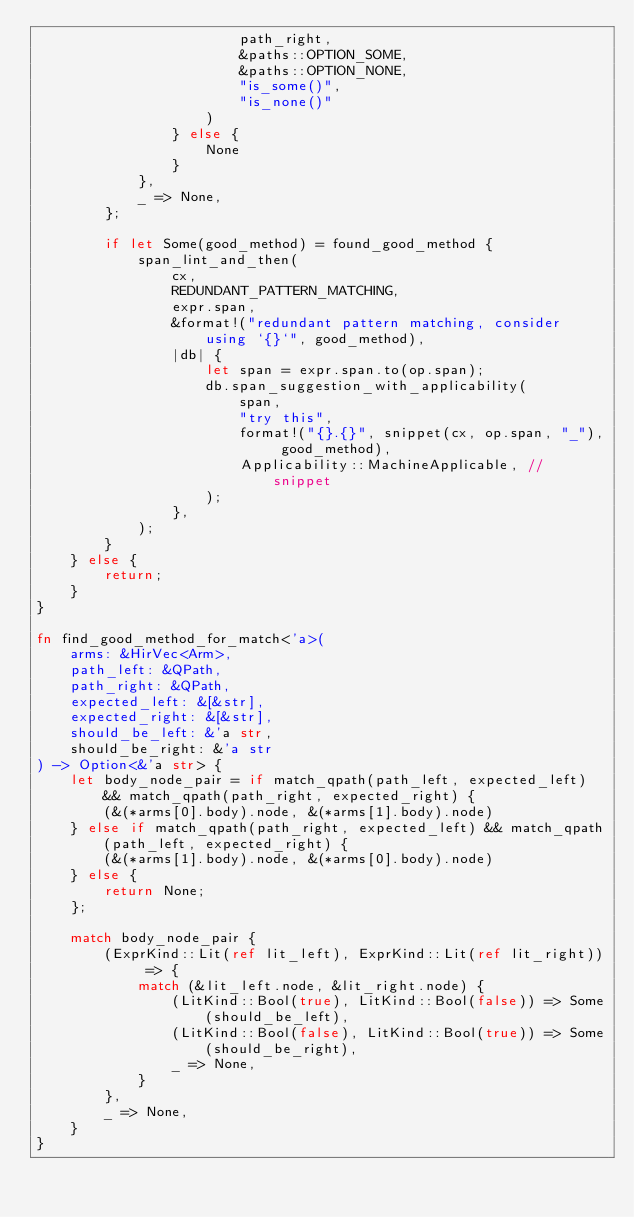<code> <loc_0><loc_0><loc_500><loc_500><_Rust_>                        path_right,
                        &paths::OPTION_SOME,
                        &paths::OPTION_NONE,
                        "is_some()",
                        "is_none()"
                    )
                } else {
                    None
                }
            },
            _ => None,
        };

        if let Some(good_method) = found_good_method {
            span_lint_and_then(
                cx,
                REDUNDANT_PATTERN_MATCHING,
                expr.span,
                &format!("redundant pattern matching, consider using `{}`", good_method),
                |db| {
                    let span = expr.span.to(op.span);
                    db.span_suggestion_with_applicability(
                        span,
                        "try this",
                        format!("{}.{}", snippet(cx, op.span, "_"), good_method),
                        Applicability::MachineApplicable, // snippet
                    );
                },
            );
        }
    } else {
        return;
    }
}

fn find_good_method_for_match<'a>(
    arms: &HirVec<Arm>,
    path_left: &QPath,
    path_right: &QPath,
    expected_left: &[&str],
    expected_right: &[&str],
    should_be_left: &'a str,
    should_be_right: &'a str
) -> Option<&'a str> {
    let body_node_pair = if match_qpath(path_left, expected_left) && match_qpath(path_right, expected_right) {
        (&(*arms[0].body).node, &(*arms[1].body).node)
    } else if match_qpath(path_right, expected_left) && match_qpath(path_left, expected_right) {
        (&(*arms[1].body).node, &(*arms[0].body).node)
    } else {
        return None;
    };

    match body_node_pair {
        (ExprKind::Lit(ref lit_left), ExprKind::Lit(ref lit_right)) => {
            match (&lit_left.node, &lit_right.node) {
                (LitKind::Bool(true), LitKind::Bool(false)) => Some(should_be_left),
                (LitKind::Bool(false), LitKind::Bool(true)) => Some(should_be_right),
                _ => None,
            }
        },
        _ => None,
    }
}
</code> 